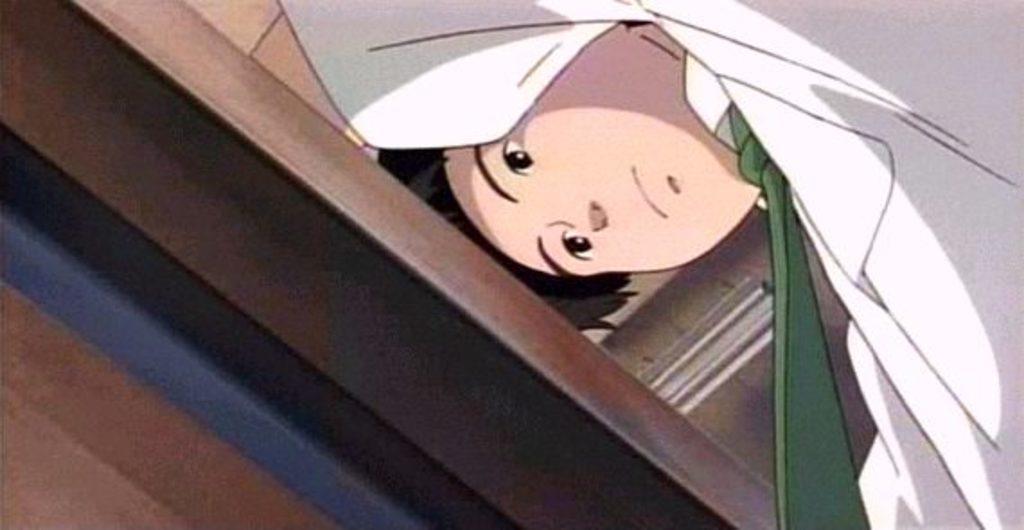How would you summarize this image in a sentence or two? This is a cartoon image of a boy, who is wearing white color shirt with green tie. 